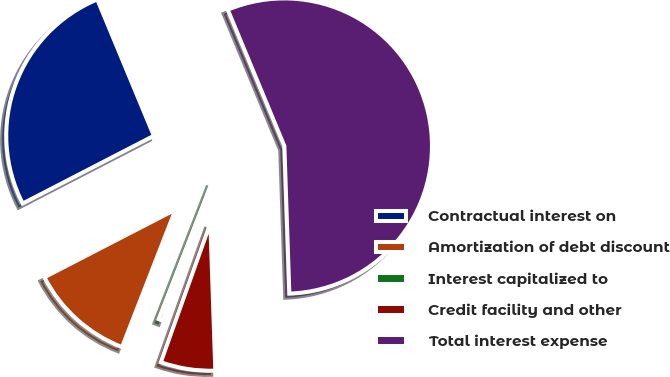Convert chart to OTSL. <chart><loc_0><loc_0><loc_500><loc_500><pie_chart><fcel>Contractual interest on<fcel>Amortization of debt discount<fcel>Interest capitalized to<fcel>Credit facility and other<fcel>Total interest expense<nl><fcel>26.32%<fcel>11.51%<fcel>0.46%<fcel>5.98%<fcel>55.72%<nl></chart> 